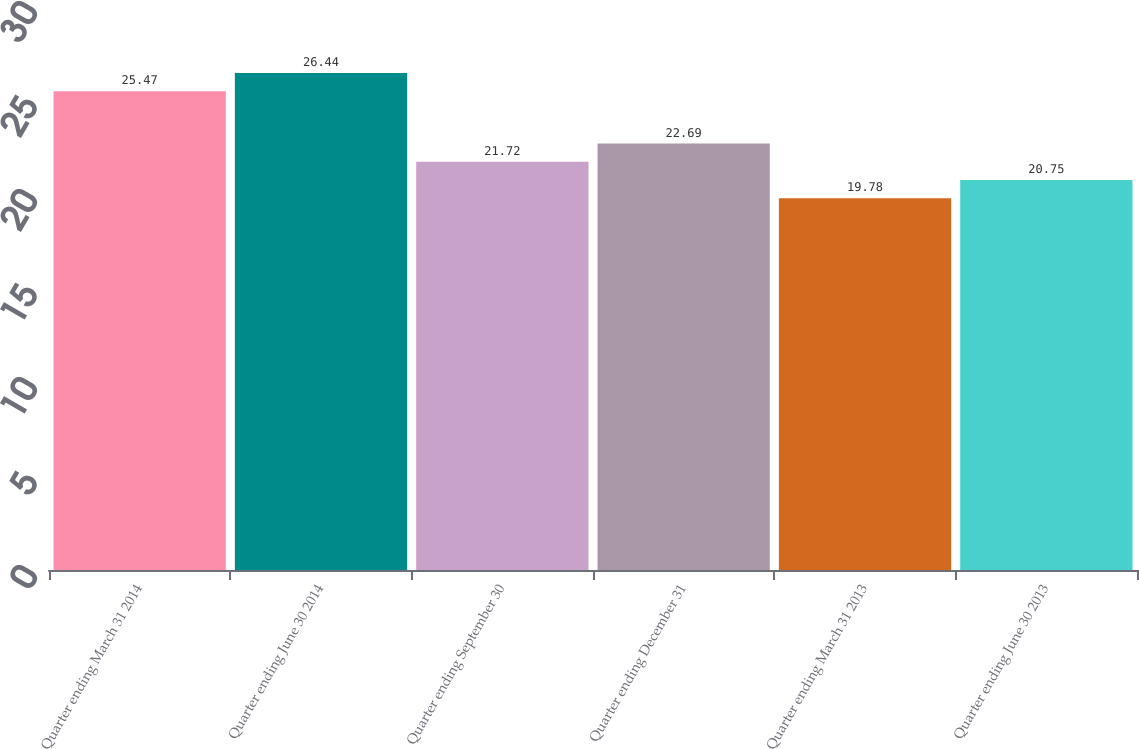Convert chart. <chart><loc_0><loc_0><loc_500><loc_500><bar_chart><fcel>Quarter ending March 31 2014<fcel>Quarter ending June 30 2014<fcel>Quarter ending September 30<fcel>Quarter ending December 31<fcel>Quarter ending March 31 2013<fcel>Quarter ending June 30 2013<nl><fcel>25.47<fcel>26.44<fcel>21.72<fcel>22.69<fcel>19.78<fcel>20.75<nl></chart> 